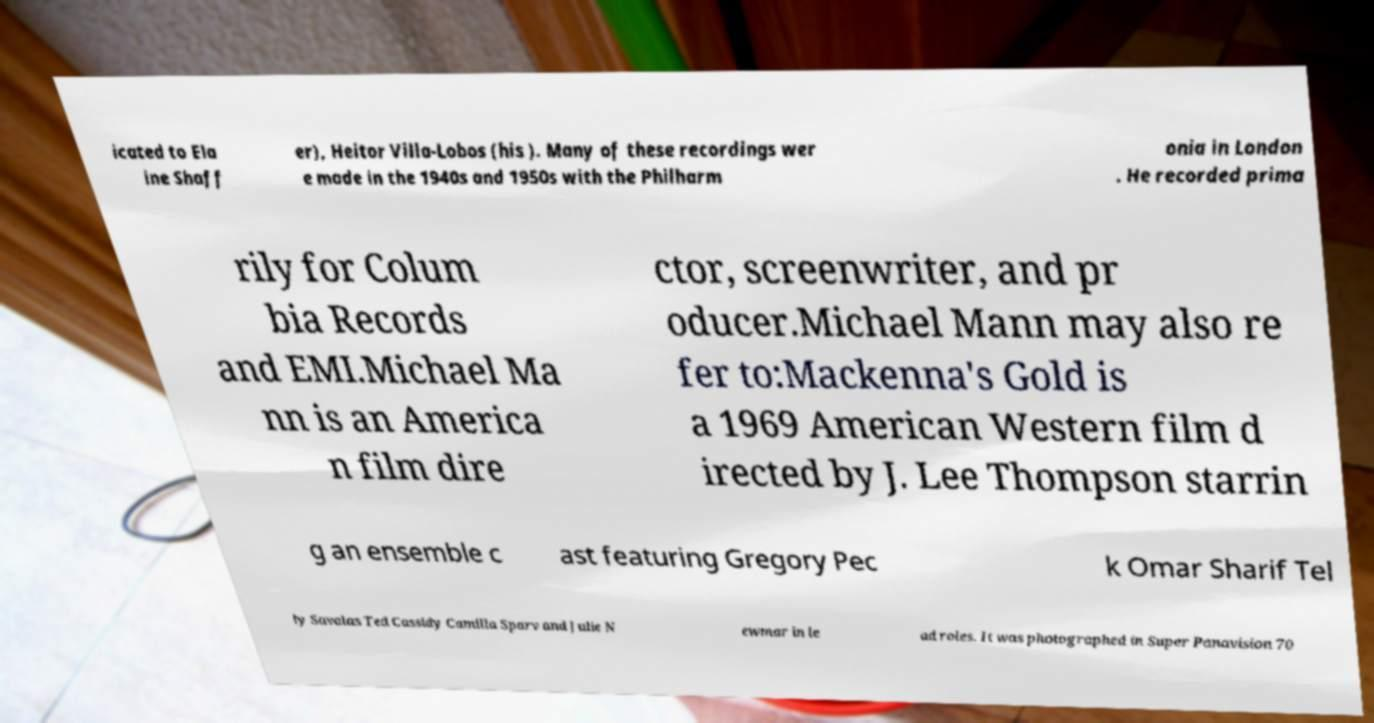There's text embedded in this image that I need extracted. Can you transcribe it verbatim? icated to Ela ine Shaff er), Heitor Villa-Lobos (his ). Many of these recordings wer e made in the 1940s and 1950s with the Philharm onia in London . He recorded prima rily for Colum bia Records and EMI.Michael Ma nn is an America n film dire ctor, screenwriter, and pr oducer.Michael Mann may also re fer to:Mackenna's Gold is a 1969 American Western film d irected by J. Lee Thompson starrin g an ensemble c ast featuring Gregory Pec k Omar Sharif Tel ly Savalas Ted Cassidy Camilla Sparv and Julie N ewmar in le ad roles. It was photographed in Super Panavision 70 